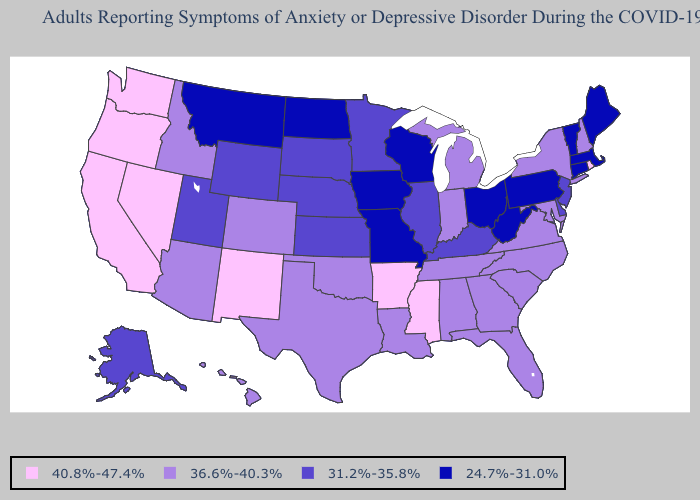Name the states that have a value in the range 40.8%-47.4%?
Short answer required. Arkansas, California, Mississippi, Nevada, New Mexico, Oregon, Rhode Island, Washington. Does Louisiana have the same value as Rhode Island?
Keep it brief. No. What is the value of Colorado?
Concise answer only. 36.6%-40.3%. Name the states that have a value in the range 40.8%-47.4%?
Answer briefly. Arkansas, California, Mississippi, Nevada, New Mexico, Oregon, Rhode Island, Washington. Does Georgia have the same value as Arizona?
Give a very brief answer. Yes. Name the states that have a value in the range 24.7%-31.0%?
Answer briefly. Connecticut, Iowa, Maine, Massachusetts, Missouri, Montana, North Dakota, Ohio, Pennsylvania, Vermont, West Virginia, Wisconsin. What is the value of Tennessee?
Short answer required. 36.6%-40.3%. Which states have the lowest value in the USA?
Short answer required. Connecticut, Iowa, Maine, Massachusetts, Missouri, Montana, North Dakota, Ohio, Pennsylvania, Vermont, West Virginia, Wisconsin. What is the value of Massachusetts?
Be succinct. 24.7%-31.0%. Name the states that have a value in the range 40.8%-47.4%?
Keep it brief. Arkansas, California, Mississippi, Nevada, New Mexico, Oregon, Rhode Island, Washington. Which states have the highest value in the USA?
Short answer required. Arkansas, California, Mississippi, Nevada, New Mexico, Oregon, Rhode Island, Washington. Is the legend a continuous bar?
Answer briefly. No. Name the states that have a value in the range 40.8%-47.4%?
Be succinct. Arkansas, California, Mississippi, Nevada, New Mexico, Oregon, Rhode Island, Washington. Does Indiana have the highest value in the USA?
Quick response, please. No. What is the highest value in the West ?
Concise answer only. 40.8%-47.4%. 